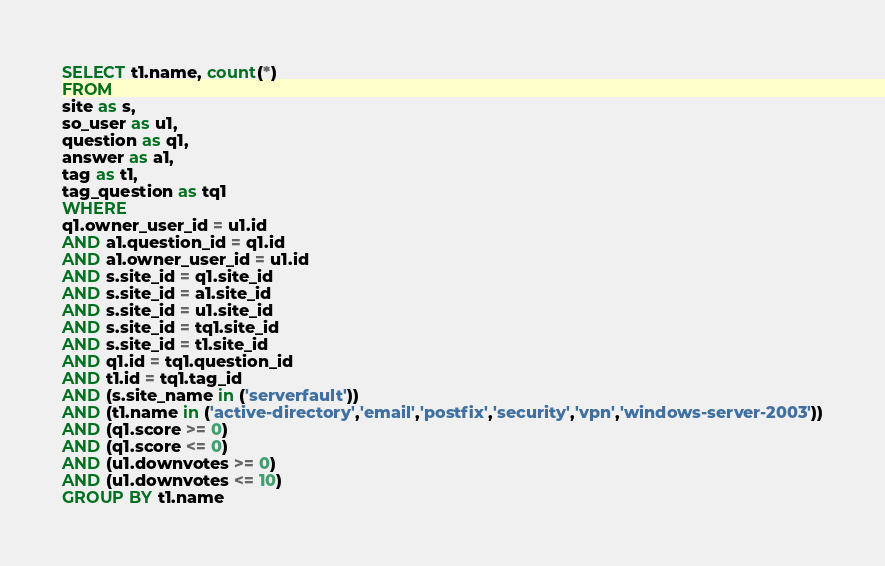Convert code to text. <code><loc_0><loc_0><loc_500><loc_500><_SQL_>SELECT t1.name, count(*)
FROM
site as s,
so_user as u1,
question as q1,
answer as a1,
tag as t1,
tag_question as tq1
WHERE
q1.owner_user_id = u1.id
AND a1.question_id = q1.id
AND a1.owner_user_id = u1.id
AND s.site_id = q1.site_id
AND s.site_id = a1.site_id
AND s.site_id = u1.site_id
AND s.site_id = tq1.site_id
AND s.site_id = t1.site_id
AND q1.id = tq1.question_id
AND t1.id = tq1.tag_id
AND (s.site_name in ('serverfault'))
AND (t1.name in ('active-directory','email','postfix','security','vpn','windows-server-2003'))
AND (q1.score >= 0)
AND (q1.score <= 0)
AND (u1.downvotes >= 0)
AND (u1.downvotes <= 10)
GROUP BY t1.name</code> 